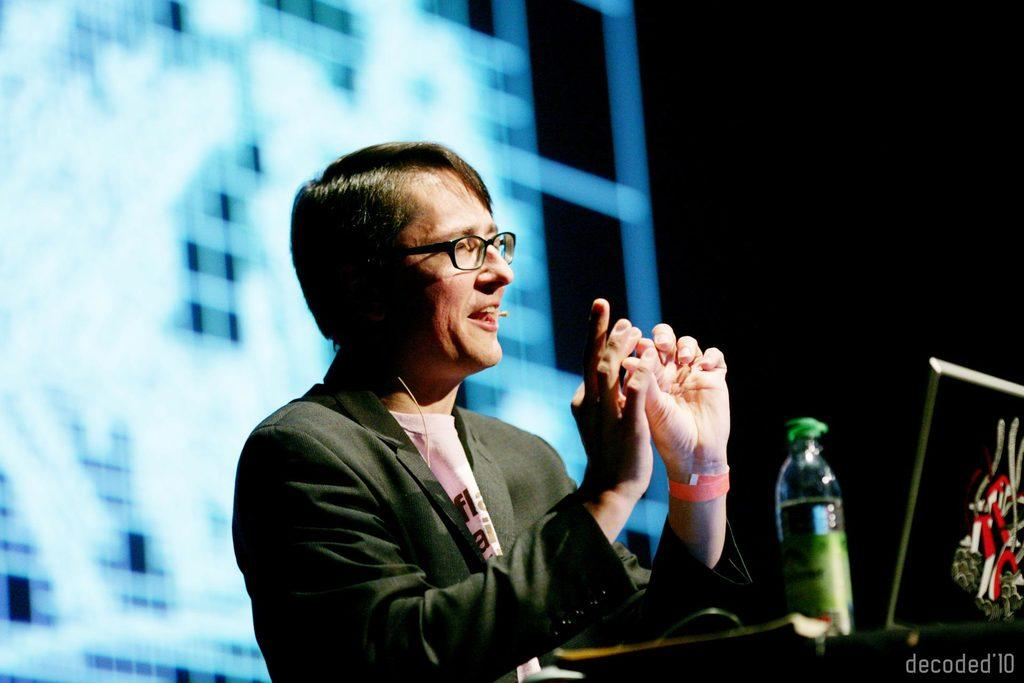What is the person in the image doing? The person is speaking into a microphone. Can you describe the person's appearance? The person is wearing glasses and a coat. What objects are in front of the person? There is a bottle and a laptop in front of the person. What type of meat is being served on the flag-themed plates in the image? There is no meat or flag-themed plates present in the image. 